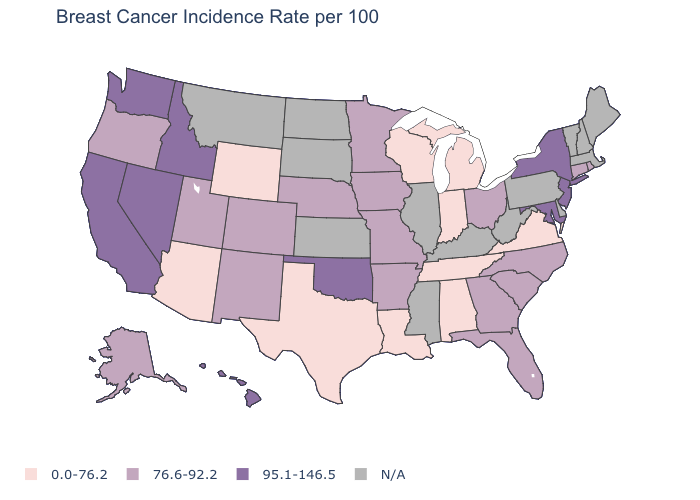Does New Mexico have the lowest value in the USA?
Give a very brief answer. No. Does the map have missing data?
Be succinct. Yes. Among the states that border Washington , which have the lowest value?
Write a very short answer. Oregon. What is the value of North Carolina?
Be succinct. 76.6-92.2. What is the value of Oregon?
Answer briefly. 76.6-92.2. Which states have the lowest value in the USA?
Keep it brief. Alabama, Arizona, Indiana, Louisiana, Michigan, Tennessee, Texas, Virginia, Wisconsin, Wyoming. What is the value of Mississippi?
Be succinct. N/A. Which states have the lowest value in the USA?
Give a very brief answer. Alabama, Arizona, Indiana, Louisiana, Michigan, Tennessee, Texas, Virginia, Wisconsin, Wyoming. Does the map have missing data?
Write a very short answer. Yes. What is the value of Oklahoma?
Concise answer only. 95.1-146.5. What is the value of Oregon?
Answer briefly. 76.6-92.2. What is the lowest value in states that border Georgia?
Short answer required. 0.0-76.2. Name the states that have a value in the range N/A?
Concise answer only. Delaware, Illinois, Kansas, Kentucky, Maine, Massachusetts, Mississippi, Montana, New Hampshire, North Dakota, Pennsylvania, South Dakota, Vermont, West Virginia. What is the value of Kentucky?
Write a very short answer. N/A. Name the states that have a value in the range 95.1-146.5?
Quick response, please. California, Hawaii, Idaho, Maryland, Nevada, New Jersey, New York, Oklahoma, Washington. 